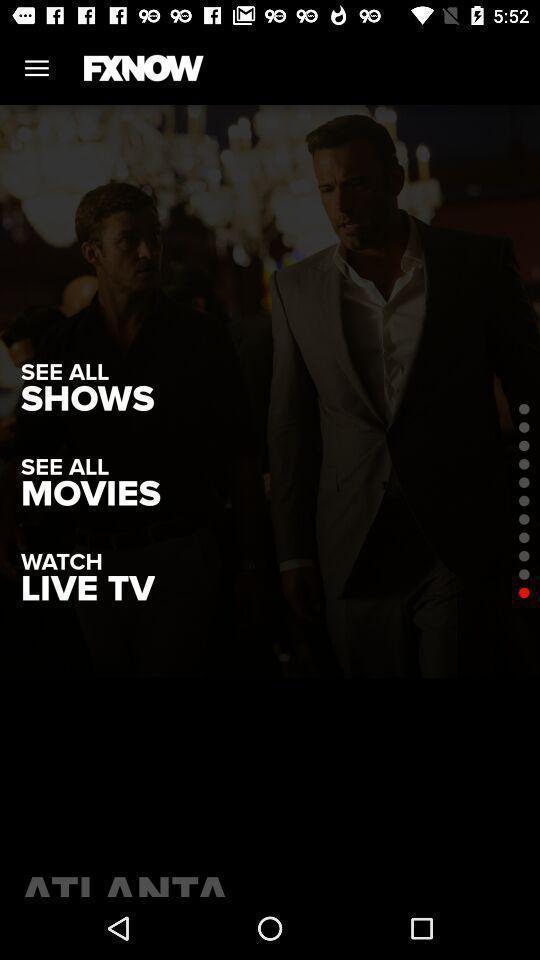Explain what's happening in this screen capture. Pages displaying episodes. 